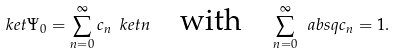Convert formula to latex. <formula><loc_0><loc_0><loc_500><loc_500>\ k e t { \Psi _ { 0 } } = \sum _ { n = 0 } ^ { \infty } c _ { n } \ k e t { n } \quad \text {with} \quad \sum _ { n = 0 } ^ { \infty } \ a b s q { c _ { n } } = 1 .</formula> 